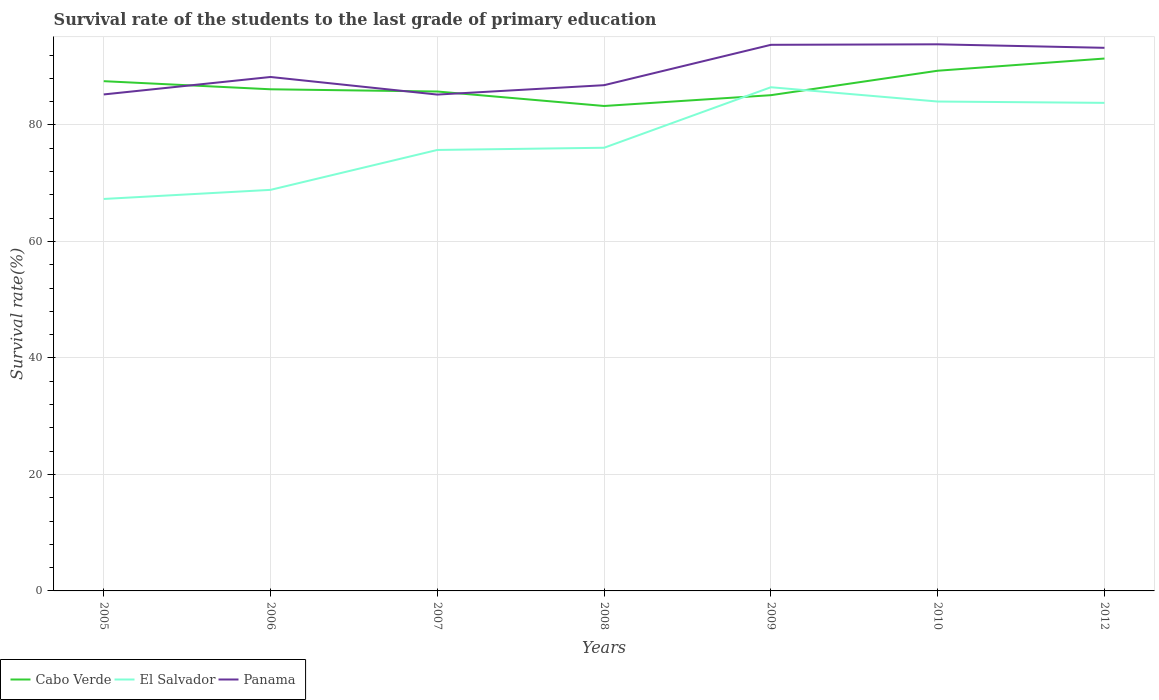Does the line corresponding to El Salvador intersect with the line corresponding to Cabo Verde?
Offer a terse response. Yes. Is the number of lines equal to the number of legend labels?
Your answer should be compact. Yes. Across all years, what is the maximum survival rate of the students in Panama?
Provide a succinct answer. 85.21. In which year was the survival rate of the students in Cabo Verde maximum?
Your answer should be compact. 2008. What is the total survival rate of the students in Cabo Verde in the graph?
Offer a terse response. 1.01. What is the difference between the highest and the second highest survival rate of the students in El Salvador?
Offer a very short reply. 19.18. Is the survival rate of the students in El Salvador strictly greater than the survival rate of the students in Panama over the years?
Make the answer very short. Yes. How many years are there in the graph?
Offer a very short reply. 7. Are the values on the major ticks of Y-axis written in scientific E-notation?
Provide a succinct answer. No. Does the graph contain any zero values?
Offer a very short reply. No. Does the graph contain grids?
Your response must be concise. Yes. How are the legend labels stacked?
Offer a very short reply. Horizontal. What is the title of the graph?
Offer a terse response. Survival rate of the students to the last grade of primary education. What is the label or title of the X-axis?
Offer a very short reply. Years. What is the label or title of the Y-axis?
Your answer should be very brief. Survival rate(%). What is the Survival rate(%) in Cabo Verde in 2005?
Your answer should be very brief. 87.51. What is the Survival rate(%) of El Salvador in 2005?
Ensure brevity in your answer.  67.29. What is the Survival rate(%) of Panama in 2005?
Offer a terse response. 85.24. What is the Survival rate(%) of Cabo Verde in 2006?
Ensure brevity in your answer.  86.12. What is the Survival rate(%) of El Salvador in 2006?
Your response must be concise. 68.86. What is the Survival rate(%) in Panama in 2006?
Offer a very short reply. 88.23. What is the Survival rate(%) in Cabo Verde in 2007?
Provide a succinct answer. 85.74. What is the Survival rate(%) of El Salvador in 2007?
Ensure brevity in your answer.  75.71. What is the Survival rate(%) of Panama in 2007?
Your response must be concise. 85.21. What is the Survival rate(%) in Cabo Verde in 2008?
Provide a succinct answer. 83.25. What is the Survival rate(%) of El Salvador in 2008?
Your answer should be compact. 76.08. What is the Survival rate(%) of Panama in 2008?
Your answer should be compact. 86.83. What is the Survival rate(%) of Cabo Verde in 2009?
Provide a short and direct response. 85.11. What is the Survival rate(%) of El Salvador in 2009?
Provide a succinct answer. 86.47. What is the Survival rate(%) in Panama in 2009?
Offer a terse response. 93.75. What is the Survival rate(%) of Cabo Verde in 2010?
Offer a very short reply. 89.31. What is the Survival rate(%) in El Salvador in 2010?
Offer a terse response. 84.02. What is the Survival rate(%) in Panama in 2010?
Provide a succinct answer. 93.84. What is the Survival rate(%) in Cabo Verde in 2012?
Provide a short and direct response. 91.4. What is the Survival rate(%) of El Salvador in 2012?
Keep it short and to the point. 83.79. What is the Survival rate(%) of Panama in 2012?
Provide a short and direct response. 93.24. Across all years, what is the maximum Survival rate(%) of Cabo Verde?
Offer a very short reply. 91.4. Across all years, what is the maximum Survival rate(%) in El Salvador?
Keep it short and to the point. 86.47. Across all years, what is the maximum Survival rate(%) of Panama?
Ensure brevity in your answer.  93.84. Across all years, what is the minimum Survival rate(%) in Cabo Verde?
Offer a terse response. 83.25. Across all years, what is the minimum Survival rate(%) of El Salvador?
Offer a terse response. 67.29. Across all years, what is the minimum Survival rate(%) of Panama?
Your answer should be compact. 85.21. What is the total Survival rate(%) of Cabo Verde in the graph?
Provide a succinct answer. 608.44. What is the total Survival rate(%) of El Salvador in the graph?
Ensure brevity in your answer.  542.22. What is the total Survival rate(%) of Panama in the graph?
Provide a succinct answer. 626.34. What is the difference between the Survival rate(%) in Cabo Verde in 2005 and that in 2006?
Offer a terse response. 1.39. What is the difference between the Survival rate(%) of El Salvador in 2005 and that in 2006?
Make the answer very short. -1.56. What is the difference between the Survival rate(%) in Panama in 2005 and that in 2006?
Your answer should be compact. -3. What is the difference between the Survival rate(%) in Cabo Verde in 2005 and that in 2007?
Give a very brief answer. 1.77. What is the difference between the Survival rate(%) of El Salvador in 2005 and that in 2007?
Give a very brief answer. -8.41. What is the difference between the Survival rate(%) of Panama in 2005 and that in 2007?
Offer a terse response. 0.02. What is the difference between the Survival rate(%) in Cabo Verde in 2005 and that in 2008?
Provide a short and direct response. 4.26. What is the difference between the Survival rate(%) in El Salvador in 2005 and that in 2008?
Provide a short and direct response. -8.79. What is the difference between the Survival rate(%) of Panama in 2005 and that in 2008?
Offer a very short reply. -1.59. What is the difference between the Survival rate(%) of Cabo Verde in 2005 and that in 2009?
Offer a very short reply. 2.4. What is the difference between the Survival rate(%) of El Salvador in 2005 and that in 2009?
Ensure brevity in your answer.  -19.18. What is the difference between the Survival rate(%) of Panama in 2005 and that in 2009?
Your answer should be compact. -8.52. What is the difference between the Survival rate(%) in Cabo Verde in 2005 and that in 2010?
Offer a very short reply. -1.79. What is the difference between the Survival rate(%) in El Salvador in 2005 and that in 2010?
Keep it short and to the point. -16.73. What is the difference between the Survival rate(%) of Panama in 2005 and that in 2010?
Offer a terse response. -8.61. What is the difference between the Survival rate(%) in Cabo Verde in 2005 and that in 2012?
Your answer should be compact. -3.89. What is the difference between the Survival rate(%) of El Salvador in 2005 and that in 2012?
Offer a terse response. -16.5. What is the difference between the Survival rate(%) of Panama in 2005 and that in 2012?
Keep it short and to the point. -8. What is the difference between the Survival rate(%) in Cabo Verde in 2006 and that in 2007?
Your answer should be compact. 0.38. What is the difference between the Survival rate(%) in El Salvador in 2006 and that in 2007?
Give a very brief answer. -6.85. What is the difference between the Survival rate(%) of Panama in 2006 and that in 2007?
Offer a terse response. 3.02. What is the difference between the Survival rate(%) in Cabo Verde in 2006 and that in 2008?
Provide a short and direct response. 2.87. What is the difference between the Survival rate(%) of El Salvador in 2006 and that in 2008?
Provide a succinct answer. -7.23. What is the difference between the Survival rate(%) in Panama in 2006 and that in 2008?
Make the answer very short. 1.41. What is the difference between the Survival rate(%) of Cabo Verde in 2006 and that in 2009?
Offer a very short reply. 1.01. What is the difference between the Survival rate(%) of El Salvador in 2006 and that in 2009?
Keep it short and to the point. -17.62. What is the difference between the Survival rate(%) of Panama in 2006 and that in 2009?
Provide a short and direct response. -5.52. What is the difference between the Survival rate(%) in Cabo Verde in 2006 and that in 2010?
Give a very brief answer. -3.18. What is the difference between the Survival rate(%) of El Salvador in 2006 and that in 2010?
Ensure brevity in your answer.  -15.16. What is the difference between the Survival rate(%) of Panama in 2006 and that in 2010?
Keep it short and to the point. -5.61. What is the difference between the Survival rate(%) of Cabo Verde in 2006 and that in 2012?
Your response must be concise. -5.28. What is the difference between the Survival rate(%) in El Salvador in 2006 and that in 2012?
Your answer should be compact. -14.93. What is the difference between the Survival rate(%) of Panama in 2006 and that in 2012?
Keep it short and to the point. -5.01. What is the difference between the Survival rate(%) of Cabo Verde in 2007 and that in 2008?
Your answer should be very brief. 2.48. What is the difference between the Survival rate(%) of El Salvador in 2007 and that in 2008?
Your answer should be compact. -0.38. What is the difference between the Survival rate(%) of Panama in 2007 and that in 2008?
Provide a succinct answer. -1.61. What is the difference between the Survival rate(%) in Cabo Verde in 2007 and that in 2009?
Ensure brevity in your answer.  0.63. What is the difference between the Survival rate(%) in El Salvador in 2007 and that in 2009?
Offer a terse response. -10.77. What is the difference between the Survival rate(%) of Panama in 2007 and that in 2009?
Offer a very short reply. -8.54. What is the difference between the Survival rate(%) of Cabo Verde in 2007 and that in 2010?
Keep it short and to the point. -3.57. What is the difference between the Survival rate(%) in El Salvador in 2007 and that in 2010?
Your response must be concise. -8.31. What is the difference between the Survival rate(%) of Panama in 2007 and that in 2010?
Provide a short and direct response. -8.63. What is the difference between the Survival rate(%) in Cabo Verde in 2007 and that in 2012?
Ensure brevity in your answer.  -5.66. What is the difference between the Survival rate(%) in El Salvador in 2007 and that in 2012?
Provide a short and direct response. -8.08. What is the difference between the Survival rate(%) in Panama in 2007 and that in 2012?
Make the answer very short. -8.03. What is the difference between the Survival rate(%) of Cabo Verde in 2008 and that in 2009?
Offer a terse response. -1.85. What is the difference between the Survival rate(%) of El Salvador in 2008 and that in 2009?
Provide a short and direct response. -10.39. What is the difference between the Survival rate(%) of Panama in 2008 and that in 2009?
Your response must be concise. -6.93. What is the difference between the Survival rate(%) of Cabo Verde in 2008 and that in 2010?
Provide a short and direct response. -6.05. What is the difference between the Survival rate(%) of El Salvador in 2008 and that in 2010?
Keep it short and to the point. -7.93. What is the difference between the Survival rate(%) of Panama in 2008 and that in 2010?
Keep it short and to the point. -7.02. What is the difference between the Survival rate(%) in Cabo Verde in 2008 and that in 2012?
Make the answer very short. -8.15. What is the difference between the Survival rate(%) in El Salvador in 2008 and that in 2012?
Offer a terse response. -7.71. What is the difference between the Survival rate(%) of Panama in 2008 and that in 2012?
Make the answer very short. -6.41. What is the difference between the Survival rate(%) of Cabo Verde in 2009 and that in 2010?
Keep it short and to the point. -4.2. What is the difference between the Survival rate(%) in El Salvador in 2009 and that in 2010?
Provide a short and direct response. 2.45. What is the difference between the Survival rate(%) in Panama in 2009 and that in 2010?
Your response must be concise. -0.09. What is the difference between the Survival rate(%) in Cabo Verde in 2009 and that in 2012?
Ensure brevity in your answer.  -6.29. What is the difference between the Survival rate(%) of El Salvador in 2009 and that in 2012?
Keep it short and to the point. 2.68. What is the difference between the Survival rate(%) in Panama in 2009 and that in 2012?
Keep it short and to the point. 0.52. What is the difference between the Survival rate(%) of Cabo Verde in 2010 and that in 2012?
Offer a very short reply. -2.09. What is the difference between the Survival rate(%) in El Salvador in 2010 and that in 2012?
Your answer should be compact. 0.23. What is the difference between the Survival rate(%) in Panama in 2010 and that in 2012?
Give a very brief answer. 0.6. What is the difference between the Survival rate(%) of Cabo Verde in 2005 and the Survival rate(%) of El Salvador in 2006?
Provide a short and direct response. 18.66. What is the difference between the Survival rate(%) of Cabo Verde in 2005 and the Survival rate(%) of Panama in 2006?
Offer a very short reply. -0.72. What is the difference between the Survival rate(%) of El Salvador in 2005 and the Survival rate(%) of Panama in 2006?
Your answer should be very brief. -20.94. What is the difference between the Survival rate(%) of Cabo Verde in 2005 and the Survival rate(%) of El Salvador in 2007?
Ensure brevity in your answer.  11.81. What is the difference between the Survival rate(%) of Cabo Verde in 2005 and the Survival rate(%) of Panama in 2007?
Offer a very short reply. 2.3. What is the difference between the Survival rate(%) of El Salvador in 2005 and the Survival rate(%) of Panama in 2007?
Your answer should be compact. -17.92. What is the difference between the Survival rate(%) of Cabo Verde in 2005 and the Survival rate(%) of El Salvador in 2008?
Your answer should be compact. 11.43. What is the difference between the Survival rate(%) in Cabo Verde in 2005 and the Survival rate(%) in Panama in 2008?
Keep it short and to the point. 0.69. What is the difference between the Survival rate(%) in El Salvador in 2005 and the Survival rate(%) in Panama in 2008?
Provide a succinct answer. -19.53. What is the difference between the Survival rate(%) in Cabo Verde in 2005 and the Survival rate(%) in El Salvador in 2009?
Offer a terse response. 1.04. What is the difference between the Survival rate(%) of Cabo Verde in 2005 and the Survival rate(%) of Panama in 2009?
Make the answer very short. -6.24. What is the difference between the Survival rate(%) of El Salvador in 2005 and the Survival rate(%) of Panama in 2009?
Keep it short and to the point. -26.46. What is the difference between the Survival rate(%) in Cabo Verde in 2005 and the Survival rate(%) in El Salvador in 2010?
Your response must be concise. 3.49. What is the difference between the Survival rate(%) of Cabo Verde in 2005 and the Survival rate(%) of Panama in 2010?
Your response must be concise. -6.33. What is the difference between the Survival rate(%) in El Salvador in 2005 and the Survival rate(%) in Panama in 2010?
Keep it short and to the point. -26.55. What is the difference between the Survival rate(%) of Cabo Verde in 2005 and the Survival rate(%) of El Salvador in 2012?
Give a very brief answer. 3.72. What is the difference between the Survival rate(%) in Cabo Verde in 2005 and the Survival rate(%) in Panama in 2012?
Keep it short and to the point. -5.73. What is the difference between the Survival rate(%) of El Salvador in 2005 and the Survival rate(%) of Panama in 2012?
Give a very brief answer. -25.95. What is the difference between the Survival rate(%) of Cabo Verde in 2006 and the Survival rate(%) of El Salvador in 2007?
Ensure brevity in your answer.  10.42. What is the difference between the Survival rate(%) in Cabo Verde in 2006 and the Survival rate(%) in Panama in 2007?
Your response must be concise. 0.91. What is the difference between the Survival rate(%) of El Salvador in 2006 and the Survival rate(%) of Panama in 2007?
Provide a short and direct response. -16.36. What is the difference between the Survival rate(%) in Cabo Verde in 2006 and the Survival rate(%) in El Salvador in 2008?
Ensure brevity in your answer.  10.04. What is the difference between the Survival rate(%) of Cabo Verde in 2006 and the Survival rate(%) of Panama in 2008?
Give a very brief answer. -0.7. What is the difference between the Survival rate(%) in El Salvador in 2006 and the Survival rate(%) in Panama in 2008?
Your answer should be very brief. -17.97. What is the difference between the Survival rate(%) in Cabo Verde in 2006 and the Survival rate(%) in El Salvador in 2009?
Make the answer very short. -0.35. What is the difference between the Survival rate(%) in Cabo Verde in 2006 and the Survival rate(%) in Panama in 2009?
Provide a succinct answer. -7.63. What is the difference between the Survival rate(%) in El Salvador in 2006 and the Survival rate(%) in Panama in 2009?
Ensure brevity in your answer.  -24.9. What is the difference between the Survival rate(%) of Cabo Verde in 2006 and the Survival rate(%) of El Salvador in 2010?
Offer a very short reply. 2.1. What is the difference between the Survival rate(%) in Cabo Verde in 2006 and the Survival rate(%) in Panama in 2010?
Your answer should be very brief. -7.72. What is the difference between the Survival rate(%) in El Salvador in 2006 and the Survival rate(%) in Panama in 2010?
Keep it short and to the point. -24.99. What is the difference between the Survival rate(%) in Cabo Verde in 2006 and the Survival rate(%) in El Salvador in 2012?
Give a very brief answer. 2.33. What is the difference between the Survival rate(%) of Cabo Verde in 2006 and the Survival rate(%) of Panama in 2012?
Offer a very short reply. -7.12. What is the difference between the Survival rate(%) of El Salvador in 2006 and the Survival rate(%) of Panama in 2012?
Your answer should be very brief. -24.38. What is the difference between the Survival rate(%) in Cabo Verde in 2007 and the Survival rate(%) in El Salvador in 2008?
Your response must be concise. 9.66. What is the difference between the Survival rate(%) in Cabo Verde in 2007 and the Survival rate(%) in Panama in 2008?
Make the answer very short. -1.09. What is the difference between the Survival rate(%) of El Salvador in 2007 and the Survival rate(%) of Panama in 2008?
Make the answer very short. -11.12. What is the difference between the Survival rate(%) of Cabo Verde in 2007 and the Survival rate(%) of El Salvador in 2009?
Your answer should be very brief. -0.73. What is the difference between the Survival rate(%) in Cabo Verde in 2007 and the Survival rate(%) in Panama in 2009?
Your answer should be very brief. -8.02. What is the difference between the Survival rate(%) of El Salvador in 2007 and the Survival rate(%) of Panama in 2009?
Keep it short and to the point. -18.05. What is the difference between the Survival rate(%) in Cabo Verde in 2007 and the Survival rate(%) in El Salvador in 2010?
Your answer should be very brief. 1.72. What is the difference between the Survival rate(%) of Cabo Verde in 2007 and the Survival rate(%) of Panama in 2010?
Provide a short and direct response. -8.1. What is the difference between the Survival rate(%) of El Salvador in 2007 and the Survival rate(%) of Panama in 2010?
Ensure brevity in your answer.  -18.14. What is the difference between the Survival rate(%) in Cabo Verde in 2007 and the Survival rate(%) in El Salvador in 2012?
Provide a succinct answer. 1.95. What is the difference between the Survival rate(%) in Cabo Verde in 2007 and the Survival rate(%) in Panama in 2012?
Your answer should be compact. -7.5. What is the difference between the Survival rate(%) in El Salvador in 2007 and the Survival rate(%) in Panama in 2012?
Provide a succinct answer. -17.53. What is the difference between the Survival rate(%) in Cabo Verde in 2008 and the Survival rate(%) in El Salvador in 2009?
Your answer should be very brief. -3.22. What is the difference between the Survival rate(%) of Cabo Verde in 2008 and the Survival rate(%) of Panama in 2009?
Ensure brevity in your answer.  -10.5. What is the difference between the Survival rate(%) of El Salvador in 2008 and the Survival rate(%) of Panama in 2009?
Make the answer very short. -17.67. What is the difference between the Survival rate(%) in Cabo Verde in 2008 and the Survival rate(%) in El Salvador in 2010?
Provide a succinct answer. -0.76. What is the difference between the Survival rate(%) in Cabo Verde in 2008 and the Survival rate(%) in Panama in 2010?
Your response must be concise. -10.59. What is the difference between the Survival rate(%) of El Salvador in 2008 and the Survival rate(%) of Panama in 2010?
Ensure brevity in your answer.  -17.76. What is the difference between the Survival rate(%) of Cabo Verde in 2008 and the Survival rate(%) of El Salvador in 2012?
Provide a succinct answer. -0.54. What is the difference between the Survival rate(%) of Cabo Verde in 2008 and the Survival rate(%) of Panama in 2012?
Give a very brief answer. -9.99. What is the difference between the Survival rate(%) in El Salvador in 2008 and the Survival rate(%) in Panama in 2012?
Your answer should be compact. -17.16. What is the difference between the Survival rate(%) of Cabo Verde in 2009 and the Survival rate(%) of El Salvador in 2010?
Provide a succinct answer. 1.09. What is the difference between the Survival rate(%) of Cabo Verde in 2009 and the Survival rate(%) of Panama in 2010?
Provide a short and direct response. -8.73. What is the difference between the Survival rate(%) of El Salvador in 2009 and the Survival rate(%) of Panama in 2010?
Keep it short and to the point. -7.37. What is the difference between the Survival rate(%) in Cabo Verde in 2009 and the Survival rate(%) in El Salvador in 2012?
Your answer should be compact. 1.32. What is the difference between the Survival rate(%) of Cabo Verde in 2009 and the Survival rate(%) of Panama in 2012?
Offer a very short reply. -8.13. What is the difference between the Survival rate(%) in El Salvador in 2009 and the Survival rate(%) in Panama in 2012?
Keep it short and to the point. -6.77. What is the difference between the Survival rate(%) of Cabo Verde in 2010 and the Survival rate(%) of El Salvador in 2012?
Offer a very short reply. 5.52. What is the difference between the Survival rate(%) of Cabo Verde in 2010 and the Survival rate(%) of Panama in 2012?
Give a very brief answer. -3.93. What is the difference between the Survival rate(%) of El Salvador in 2010 and the Survival rate(%) of Panama in 2012?
Provide a short and direct response. -9.22. What is the average Survival rate(%) in Cabo Verde per year?
Offer a terse response. 86.92. What is the average Survival rate(%) in El Salvador per year?
Provide a short and direct response. 77.46. What is the average Survival rate(%) in Panama per year?
Provide a short and direct response. 89.48. In the year 2005, what is the difference between the Survival rate(%) of Cabo Verde and Survival rate(%) of El Salvador?
Offer a terse response. 20.22. In the year 2005, what is the difference between the Survival rate(%) of Cabo Verde and Survival rate(%) of Panama?
Offer a terse response. 2.28. In the year 2005, what is the difference between the Survival rate(%) in El Salvador and Survival rate(%) in Panama?
Offer a terse response. -17.94. In the year 2006, what is the difference between the Survival rate(%) of Cabo Verde and Survival rate(%) of El Salvador?
Offer a very short reply. 17.27. In the year 2006, what is the difference between the Survival rate(%) in Cabo Verde and Survival rate(%) in Panama?
Offer a terse response. -2.11. In the year 2006, what is the difference between the Survival rate(%) of El Salvador and Survival rate(%) of Panama?
Provide a succinct answer. -19.38. In the year 2007, what is the difference between the Survival rate(%) of Cabo Verde and Survival rate(%) of El Salvador?
Your answer should be compact. 10.03. In the year 2007, what is the difference between the Survival rate(%) of Cabo Verde and Survival rate(%) of Panama?
Your answer should be compact. 0.53. In the year 2007, what is the difference between the Survival rate(%) of El Salvador and Survival rate(%) of Panama?
Provide a short and direct response. -9.51. In the year 2008, what is the difference between the Survival rate(%) in Cabo Verde and Survival rate(%) in El Salvador?
Your answer should be very brief. 7.17. In the year 2008, what is the difference between the Survival rate(%) of Cabo Verde and Survival rate(%) of Panama?
Your answer should be very brief. -3.57. In the year 2008, what is the difference between the Survival rate(%) in El Salvador and Survival rate(%) in Panama?
Give a very brief answer. -10.74. In the year 2009, what is the difference between the Survival rate(%) of Cabo Verde and Survival rate(%) of El Salvador?
Make the answer very short. -1.36. In the year 2009, what is the difference between the Survival rate(%) of Cabo Verde and Survival rate(%) of Panama?
Give a very brief answer. -8.65. In the year 2009, what is the difference between the Survival rate(%) in El Salvador and Survival rate(%) in Panama?
Your response must be concise. -7.28. In the year 2010, what is the difference between the Survival rate(%) of Cabo Verde and Survival rate(%) of El Salvador?
Keep it short and to the point. 5.29. In the year 2010, what is the difference between the Survival rate(%) of Cabo Verde and Survival rate(%) of Panama?
Your answer should be compact. -4.54. In the year 2010, what is the difference between the Survival rate(%) of El Salvador and Survival rate(%) of Panama?
Your answer should be compact. -9.82. In the year 2012, what is the difference between the Survival rate(%) in Cabo Verde and Survival rate(%) in El Salvador?
Offer a very short reply. 7.61. In the year 2012, what is the difference between the Survival rate(%) of Cabo Verde and Survival rate(%) of Panama?
Keep it short and to the point. -1.84. In the year 2012, what is the difference between the Survival rate(%) in El Salvador and Survival rate(%) in Panama?
Offer a very short reply. -9.45. What is the ratio of the Survival rate(%) of Cabo Verde in 2005 to that in 2006?
Provide a short and direct response. 1.02. What is the ratio of the Survival rate(%) in El Salvador in 2005 to that in 2006?
Give a very brief answer. 0.98. What is the ratio of the Survival rate(%) of Cabo Verde in 2005 to that in 2007?
Provide a short and direct response. 1.02. What is the ratio of the Survival rate(%) of Cabo Verde in 2005 to that in 2008?
Give a very brief answer. 1.05. What is the ratio of the Survival rate(%) in El Salvador in 2005 to that in 2008?
Ensure brevity in your answer.  0.88. What is the ratio of the Survival rate(%) of Panama in 2005 to that in 2008?
Keep it short and to the point. 0.98. What is the ratio of the Survival rate(%) of Cabo Verde in 2005 to that in 2009?
Your answer should be compact. 1.03. What is the ratio of the Survival rate(%) of El Salvador in 2005 to that in 2009?
Give a very brief answer. 0.78. What is the ratio of the Survival rate(%) in Panama in 2005 to that in 2009?
Your response must be concise. 0.91. What is the ratio of the Survival rate(%) of Cabo Verde in 2005 to that in 2010?
Your response must be concise. 0.98. What is the ratio of the Survival rate(%) in El Salvador in 2005 to that in 2010?
Keep it short and to the point. 0.8. What is the ratio of the Survival rate(%) in Panama in 2005 to that in 2010?
Your answer should be very brief. 0.91. What is the ratio of the Survival rate(%) in Cabo Verde in 2005 to that in 2012?
Provide a short and direct response. 0.96. What is the ratio of the Survival rate(%) of El Salvador in 2005 to that in 2012?
Give a very brief answer. 0.8. What is the ratio of the Survival rate(%) of Panama in 2005 to that in 2012?
Your response must be concise. 0.91. What is the ratio of the Survival rate(%) of El Salvador in 2006 to that in 2007?
Your answer should be compact. 0.91. What is the ratio of the Survival rate(%) in Panama in 2006 to that in 2007?
Your response must be concise. 1.04. What is the ratio of the Survival rate(%) of Cabo Verde in 2006 to that in 2008?
Ensure brevity in your answer.  1.03. What is the ratio of the Survival rate(%) of El Salvador in 2006 to that in 2008?
Keep it short and to the point. 0.91. What is the ratio of the Survival rate(%) in Panama in 2006 to that in 2008?
Offer a very short reply. 1.02. What is the ratio of the Survival rate(%) in Cabo Verde in 2006 to that in 2009?
Provide a succinct answer. 1.01. What is the ratio of the Survival rate(%) in El Salvador in 2006 to that in 2009?
Your response must be concise. 0.8. What is the ratio of the Survival rate(%) of Panama in 2006 to that in 2009?
Make the answer very short. 0.94. What is the ratio of the Survival rate(%) of El Salvador in 2006 to that in 2010?
Your response must be concise. 0.82. What is the ratio of the Survival rate(%) in Panama in 2006 to that in 2010?
Your answer should be compact. 0.94. What is the ratio of the Survival rate(%) of Cabo Verde in 2006 to that in 2012?
Provide a succinct answer. 0.94. What is the ratio of the Survival rate(%) in El Salvador in 2006 to that in 2012?
Make the answer very short. 0.82. What is the ratio of the Survival rate(%) of Panama in 2006 to that in 2012?
Your response must be concise. 0.95. What is the ratio of the Survival rate(%) in Cabo Verde in 2007 to that in 2008?
Provide a succinct answer. 1.03. What is the ratio of the Survival rate(%) in Panama in 2007 to that in 2008?
Your answer should be very brief. 0.98. What is the ratio of the Survival rate(%) in Cabo Verde in 2007 to that in 2009?
Offer a terse response. 1.01. What is the ratio of the Survival rate(%) of El Salvador in 2007 to that in 2009?
Provide a short and direct response. 0.88. What is the ratio of the Survival rate(%) in Panama in 2007 to that in 2009?
Make the answer very short. 0.91. What is the ratio of the Survival rate(%) of Cabo Verde in 2007 to that in 2010?
Your response must be concise. 0.96. What is the ratio of the Survival rate(%) of El Salvador in 2007 to that in 2010?
Your answer should be very brief. 0.9. What is the ratio of the Survival rate(%) of Panama in 2007 to that in 2010?
Your answer should be compact. 0.91. What is the ratio of the Survival rate(%) of Cabo Verde in 2007 to that in 2012?
Offer a very short reply. 0.94. What is the ratio of the Survival rate(%) in El Salvador in 2007 to that in 2012?
Your response must be concise. 0.9. What is the ratio of the Survival rate(%) in Panama in 2007 to that in 2012?
Your answer should be very brief. 0.91. What is the ratio of the Survival rate(%) of Cabo Verde in 2008 to that in 2009?
Ensure brevity in your answer.  0.98. What is the ratio of the Survival rate(%) of El Salvador in 2008 to that in 2009?
Your answer should be very brief. 0.88. What is the ratio of the Survival rate(%) of Panama in 2008 to that in 2009?
Offer a terse response. 0.93. What is the ratio of the Survival rate(%) of Cabo Verde in 2008 to that in 2010?
Offer a very short reply. 0.93. What is the ratio of the Survival rate(%) of El Salvador in 2008 to that in 2010?
Provide a succinct answer. 0.91. What is the ratio of the Survival rate(%) of Panama in 2008 to that in 2010?
Keep it short and to the point. 0.93. What is the ratio of the Survival rate(%) of Cabo Verde in 2008 to that in 2012?
Your answer should be compact. 0.91. What is the ratio of the Survival rate(%) in El Salvador in 2008 to that in 2012?
Ensure brevity in your answer.  0.91. What is the ratio of the Survival rate(%) in Panama in 2008 to that in 2012?
Provide a short and direct response. 0.93. What is the ratio of the Survival rate(%) of Cabo Verde in 2009 to that in 2010?
Your answer should be very brief. 0.95. What is the ratio of the Survival rate(%) of El Salvador in 2009 to that in 2010?
Your answer should be very brief. 1.03. What is the ratio of the Survival rate(%) of Cabo Verde in 2009 to that in 2012?
Offer a very short reply. 0.93. What is the ratio of the Survival rate(%) of El Salvador in 2009 to that in 2012?
Your answer should be very brief. 1.03. What is the ratio of the Survival rate(%) in Panama in 2009 to that in 2012?
Provide a short and direct response. 1.01. What is the ratio of the Survival rate(%) of Cabo Verde in 2010 to that in 2012?
Ensure brevity in your answer.  0.98. What is the ratio of the Survival rate(%) of El Salvador in 2010 to that in 2012?
Your response must be concise. 1. What is the difference between the highest and the second highest Survival rate(%) in Cabo Verde?
Your answer should be very brief. 2.09. What is the difference between the highest and the second highest Survival rate(%) of El Salvador?
Keep it short and to the point. 2.45. What is the difference between the highest and the second highest Survival rate(%) in Panama?
Offer a very short reply. 0.09. What is the difference between the highest and the lowest Survival rate(%) of Cabo Verde?
Your answer should be very brief. 8.15. What is the difference between the highest and the lowest Survival rate(%) of El Salvador?
Offer a terse response. 19.18. What is the difference between the highest and the lowest Survival rate(%) of Panama?
Give a very brief answer. 8.63. 